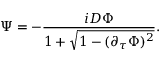<formula> <loc_0><loc_0><loc_500><loc_500>\Psi = - { \frac { i D \Phi } { 1 + \sqrt { 1 - ( \partial _ { \tau } \Phi ) ^ { 2 } } } } .</formula> 